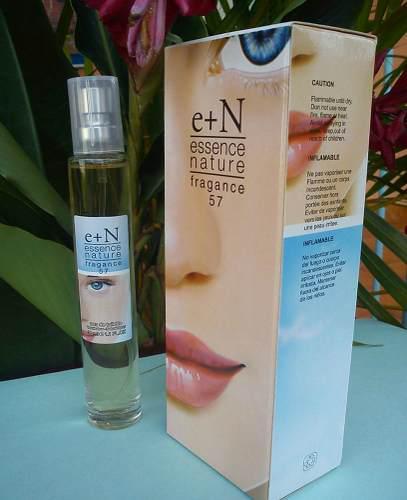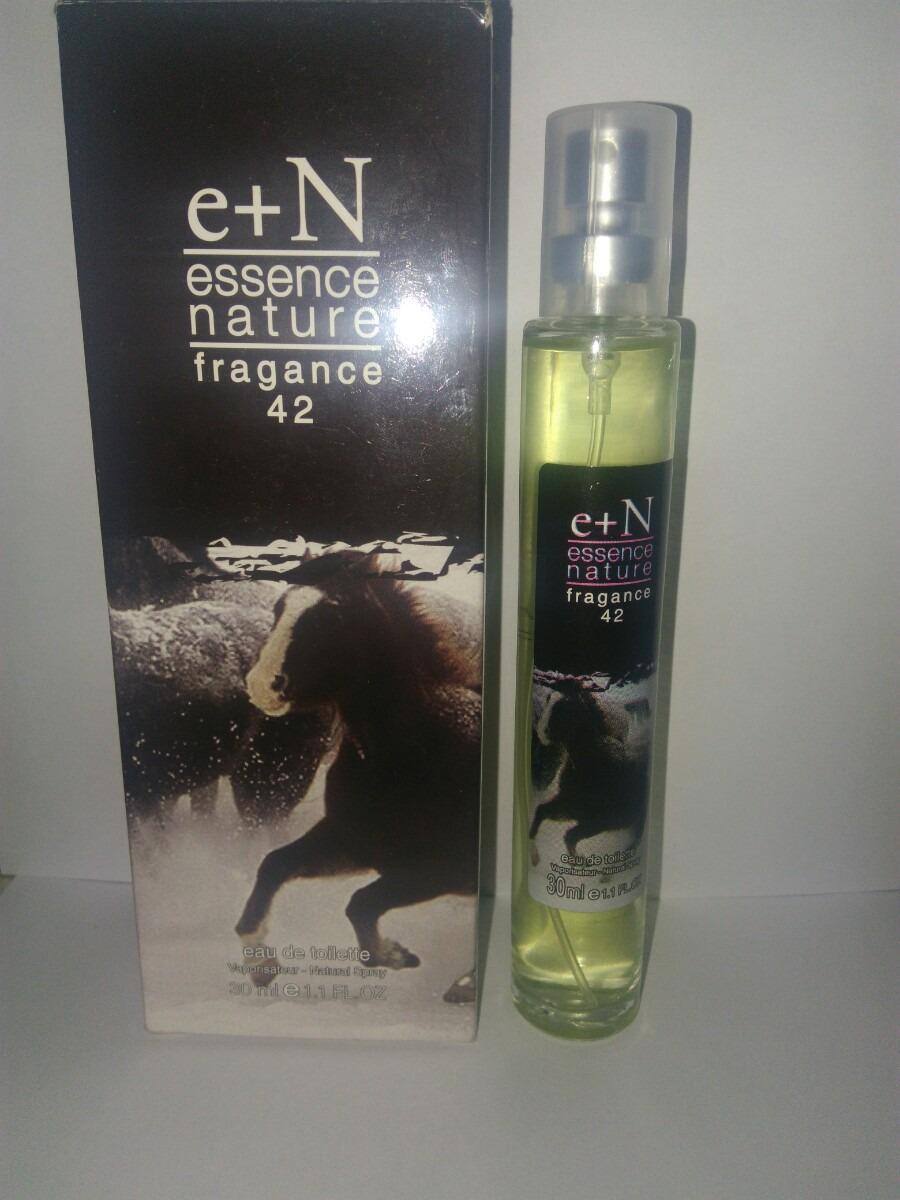The first image is the image on the left, the second image is the image on the right. Examine the images to the left and right. Is the description "One of the product boxes has a red flower on the front." accurate? Answer yes or no. No. The first image is the image on the left, the second image is the image on the right. Considering the images on both sides, is "One image shows a slender bottle upright next to a box with half of a woman's face on it's front." valid? Answer yes or no. Yes. 